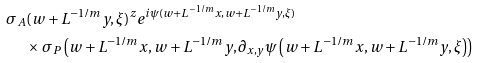<formula> <loc_0><loc_0><loc_500><loc_500>\sigma _ { A } & ( w + L ^ { - 1 / m } y , \xi ) ^ { z } e ^ { i \psi ( w + L ^ { - 1 / m } x , w + L ^ { - 1 / m } y , \xi ) } \\ & \times \sigma _ { P } \left ( w + L ^ { - 1 / m } x , w + L ^ { - 1 / m } y , \partial _ { x , y } \psi \left ( w + L ^ { - 1 / m } x , w + L ^ { - 1 / m } y , \xi \right ) \right )</formula> 